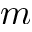<formula> <loc_0><loc_0><loc_500><loc_500>m</formula> 